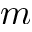<formula> <loc_0><loc_0><loc_500><loc_500>m</formula> 